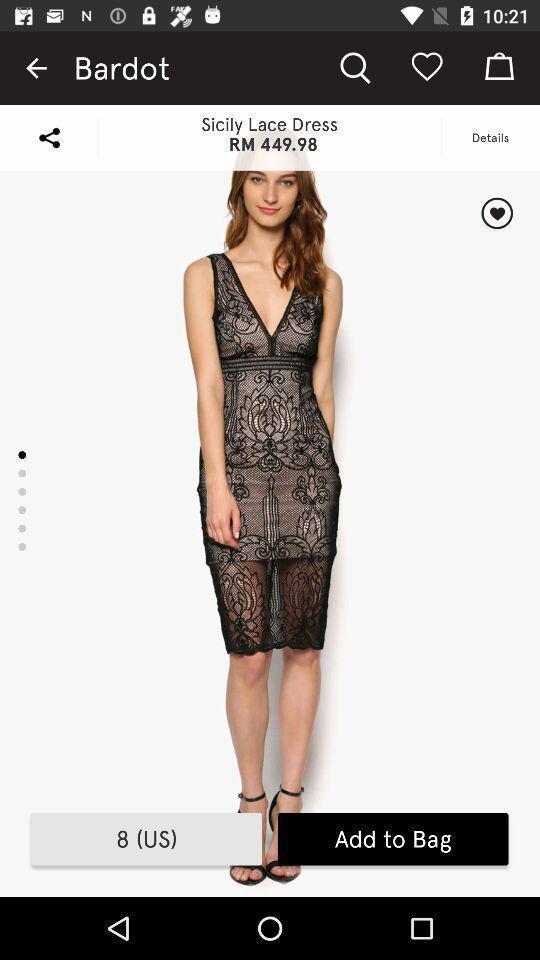Describe this image in words. Screen shows dress in a shopping app. 